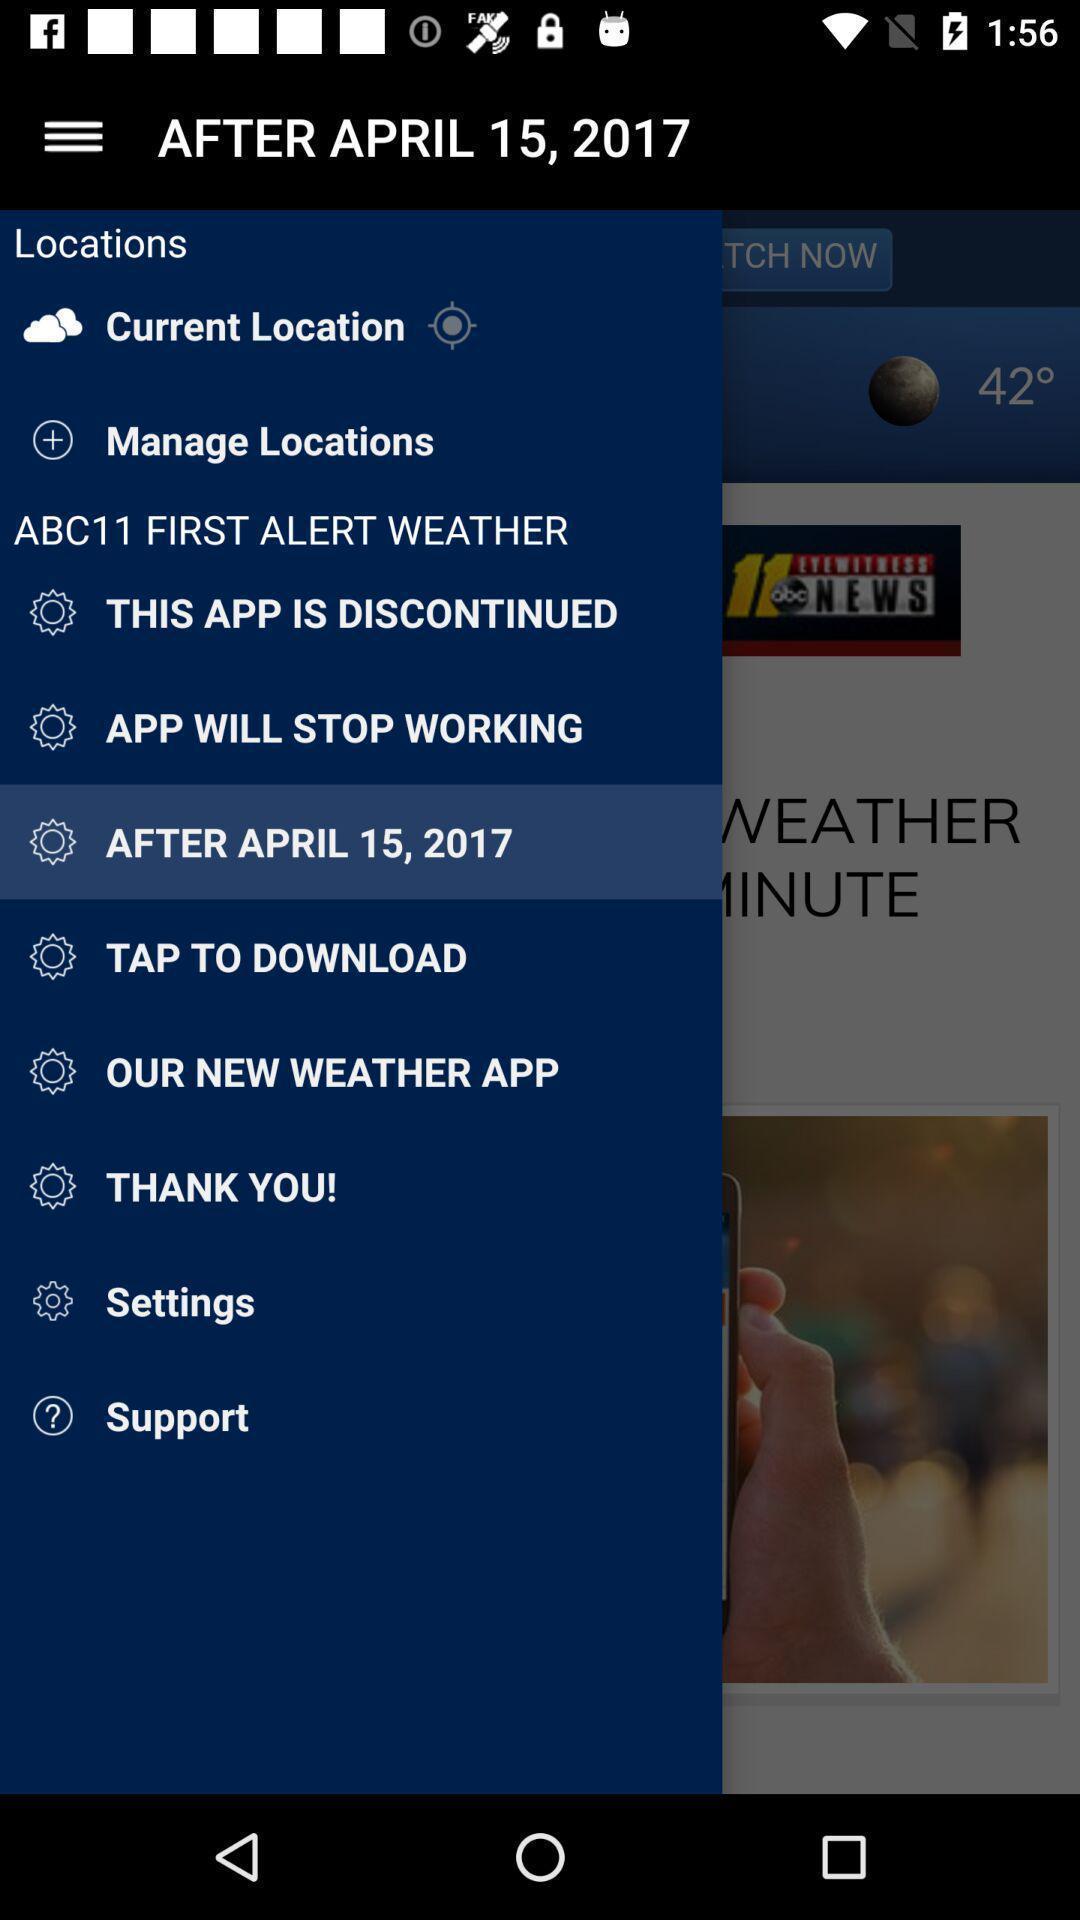Explain what's happening in this screen capture. Sidebar menu list. 